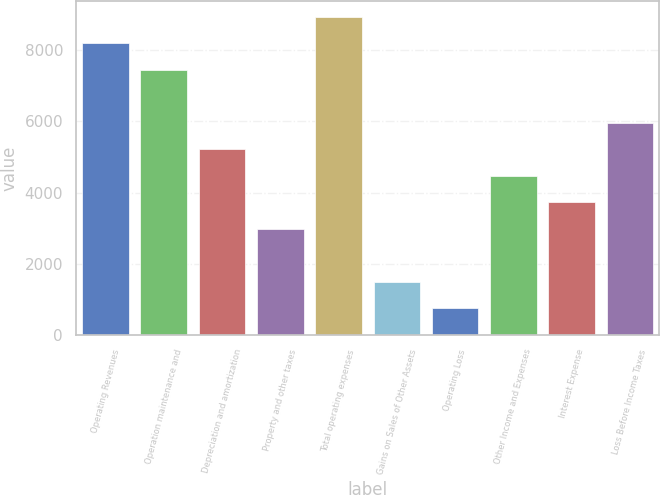Convert chart to OTSL. <chart><loc_0><loc_0><loc_500><loc_500><bar_chart><fcel>Operating Revenues<fcel>Operation maintenance and<fcel>Depreciation and amortization<fcel>Property and other taxes<fcel>Total operating expenses<fcel>Gains on Sales of Other Assets<fcel>Operating Loss<fcel>Other Income and Expenses<fcel>Interest Expense<fcel>Loss Before Income Taxes<nl><fcel>8190.4<fcel>7446<fcel>5212.8<fcel>2979.6<fcel>8934.8<fcel>1490.8<fcel>746.4<fcel>4468.4<fcel>3724<fcel>5957.2<nl></chart> 